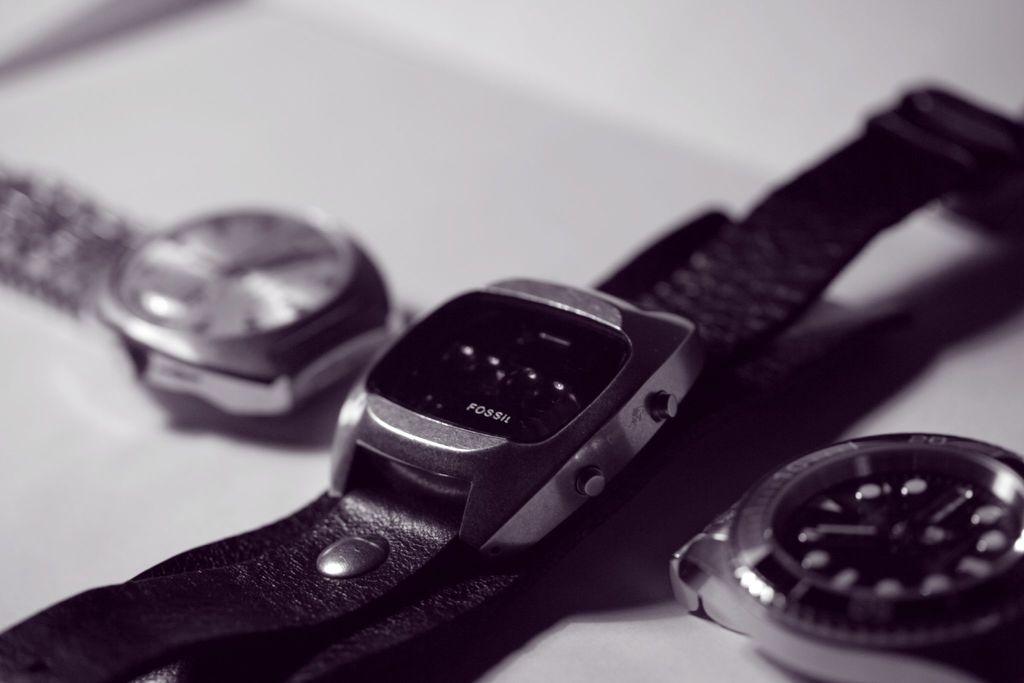What is the brand of watch?
Give a very brief answer. Fossil. 